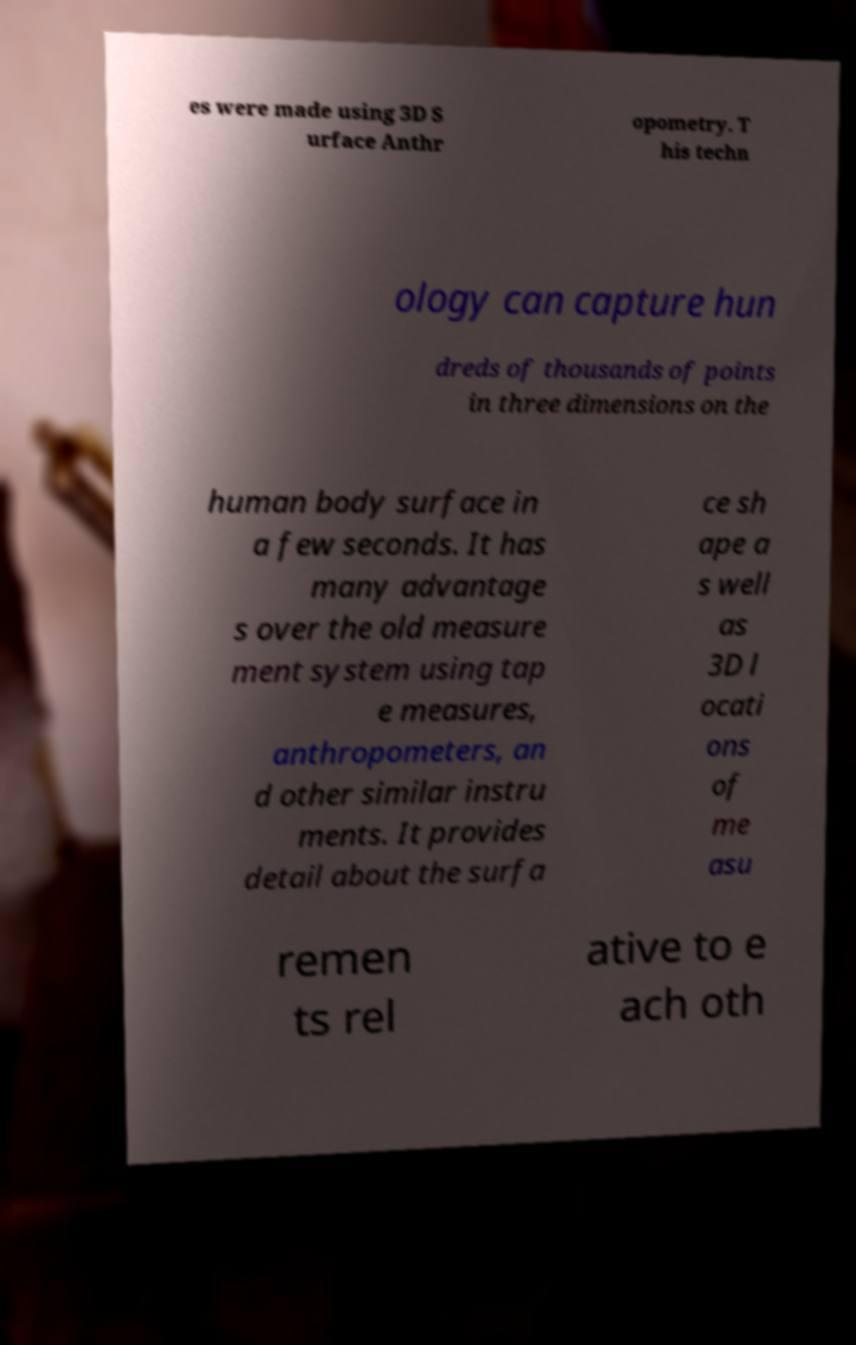There's text embedded in this image that I need extracted. Can you transcribe it verbatim? es were made using 3D S urface Anthr opometry. T his techn ology can capture hun dreds of thousands of points in three dimensions on the human body surface in a few seconds. It has many advantage s over the old measure ment system using tap e measures, anthropometers, an d other similar instru ments. It provides detail about the surfa ce sh ape a s well as 3D l ocati ons of me asu remen ts rel ative to e ach oth 